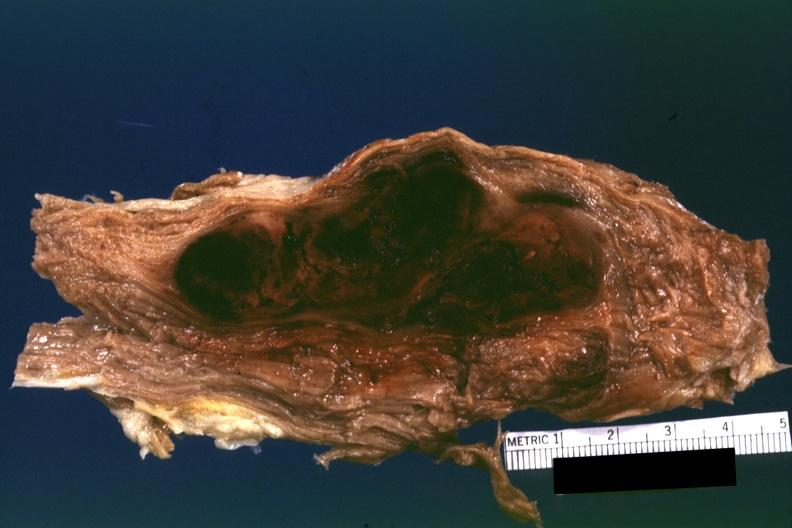s soft tissue present?
Answer the question using a single word or phrase. Yes 